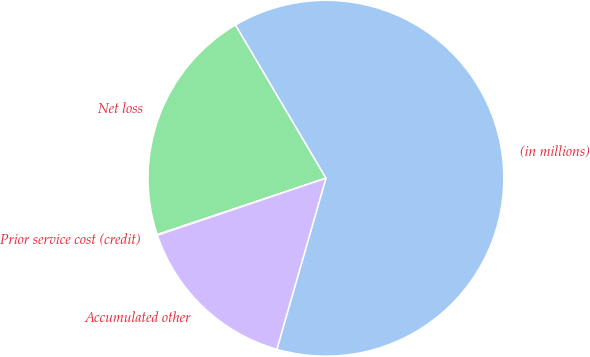Convert chart to OTSL. <chart><loc_0><loc_0><loc_500><loc_500><pie_chart><fcel>(in millions)<fcel>Net loss<fcel>Prior service cost (credit)<fcel>Accumulated other<nl><fcel>62.93%<fcel>21.64%<fcel>0.06%<fcel>15.36%<nl></chart> 